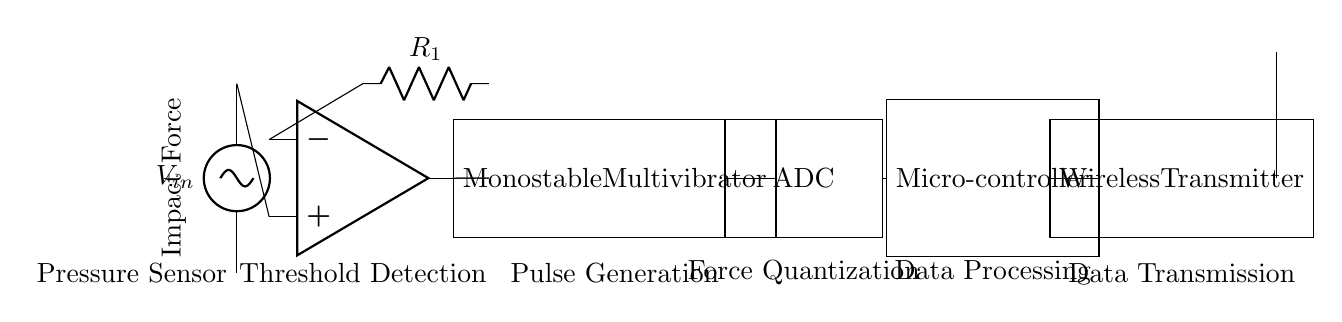What is the main component that detects impact force? The primary component responsible for detecting impact force is the pressure sensor, which is indicated at the start of the circuit diagram.
Answer: Pressure sensor What type of device is represented by the component labeled "Microcontroller"? The microcontroller is a processing unit in the circuit that takes digital data from the ADC and processes it for further use, particularly for data transmission.
Answer: Processing unit How many main functional blocks are shown in the circuit? There are five main functional blocks, which include the pressure sensor, comparator, monostable multivibrator, ADC, and microcontroller.
Answer: Five What happens in the "Monostable" block? The monostable multivibrator generates a single output pulse in response to a triggering input, which is used for pulse generation in timing applications.
Answer: Generates pulse Which component evaluates the signal threshold? The comparator evaluates the signal threshold, comparing the output from the pressure sensor against a reference voltage to determine if the impact force exceeds a set level.
Answer: Comparator What is the purpose of the wireless transmitter in the circuit? The wireless transmitter sends the processed data from the microcontroller to a remote receiver, facilitating data communication without physical connections.
Answer: Data transmission What type of circuit configuration is employed in this design? The design is an event-driven asynchronous circuit, as it reacts to input signals (landing forces) without requiring a continuous clock signal for operation.
Answer: Event-driven asynchronous 